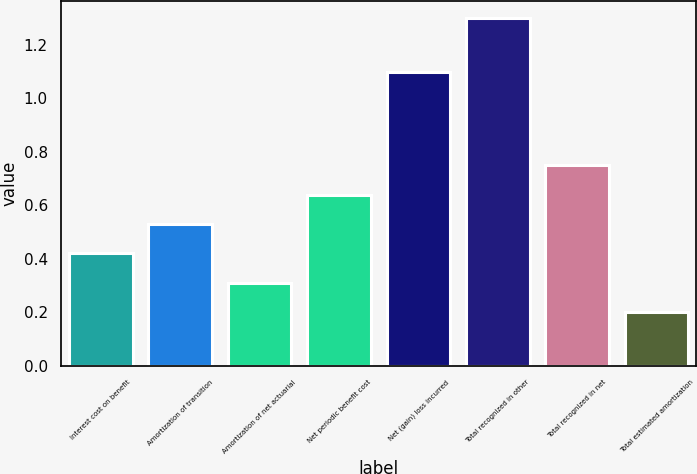Convert chart to OTSL. <chart><loc_0><loc_0><loc_500><loc_500><bar_chart><fcel>Interest cost on benefit<fcel>Amortization of transition<fcel>Amortization of net actuarial<fcel>Net periodic benefit cost<fcel>Net (gain) loss incurred<fcel>Total recognized in other<fcel>Total recognized in net<fcel>Total estimated amortization<nl><fcel>0.42<fcel>0.53<fcel>0.31<fcel>0.64<fcel>1.1<fcel>1.3<fcel>0.75<fcel>0.2<nl></chart> 